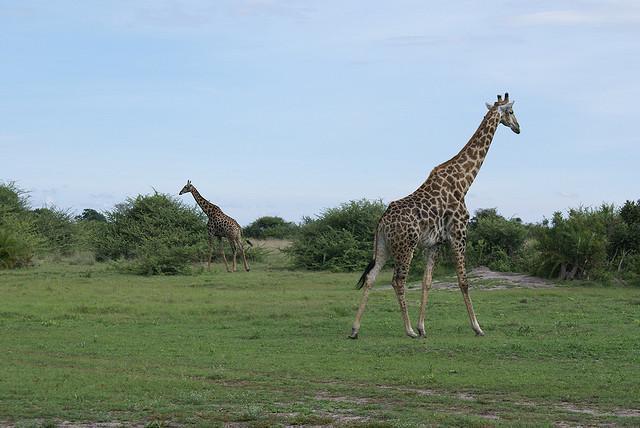How many trees?
Give a very brief answer. 0. How many animals are at this location?
Give a very brief answer. 2. How many giraffes are there?
Give a very brief answer. 1. How many men wear a hat?
Give a very brief answer. 0. 